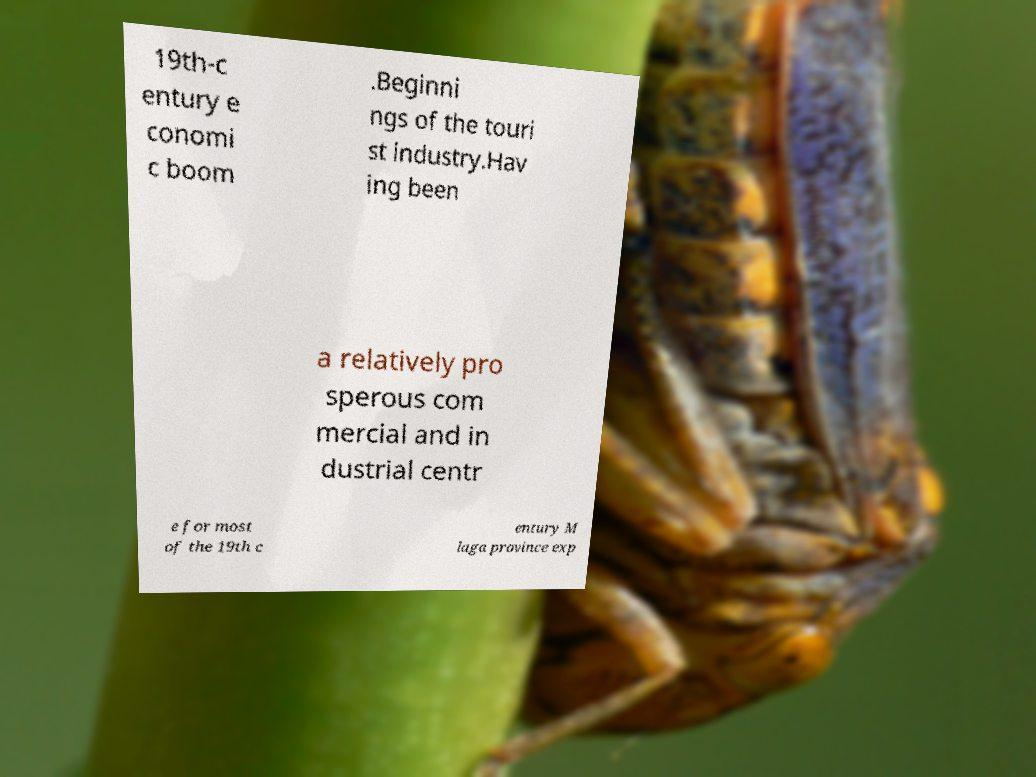Could you assist in decoding the text presented in this image and type it out clearly? 19th-c entury e conomi c boom .Beginni ngs of the touri st industry.Hav ing been a relatively pro sperous com mercial and in dustrial centr e for most of the 19th c entury M laga province exp 